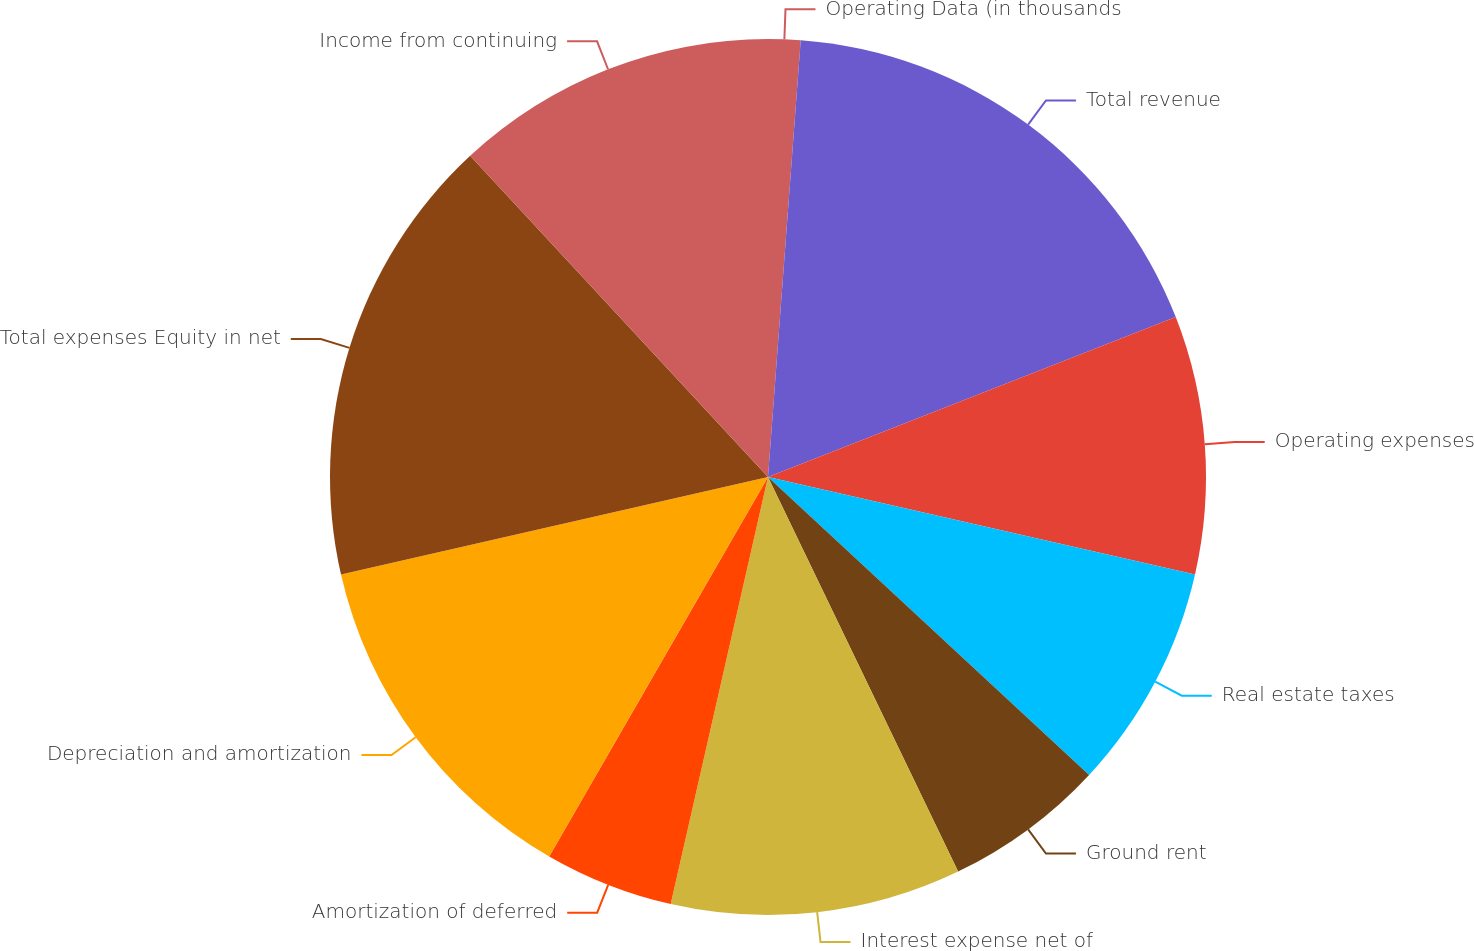Convert chart to OTSL. <chart><loc_0><loc_0><loc_500><loc_500><pie_chart><fcel>Operating Data (in thousands<fcel>Total revenue<fcel>Operating expenses<fcel>Real estate taxes<fcel>Ground rent<fcel>Interest expense net of<fcel>Amortization of deferred<fcel>Depreciation and amortization<fcel>Total expenses Equity in net<fcel>Income from continuing<nl><fcel>1.19%<fcel>17.86%<fcel>9.52%<fcel>8.33%<fcel>5.95%<fcel>10.71%<fcel>4.76%<fcel>13.1%<fcel>16.67%<fcel>11.9%<nl></chart> 